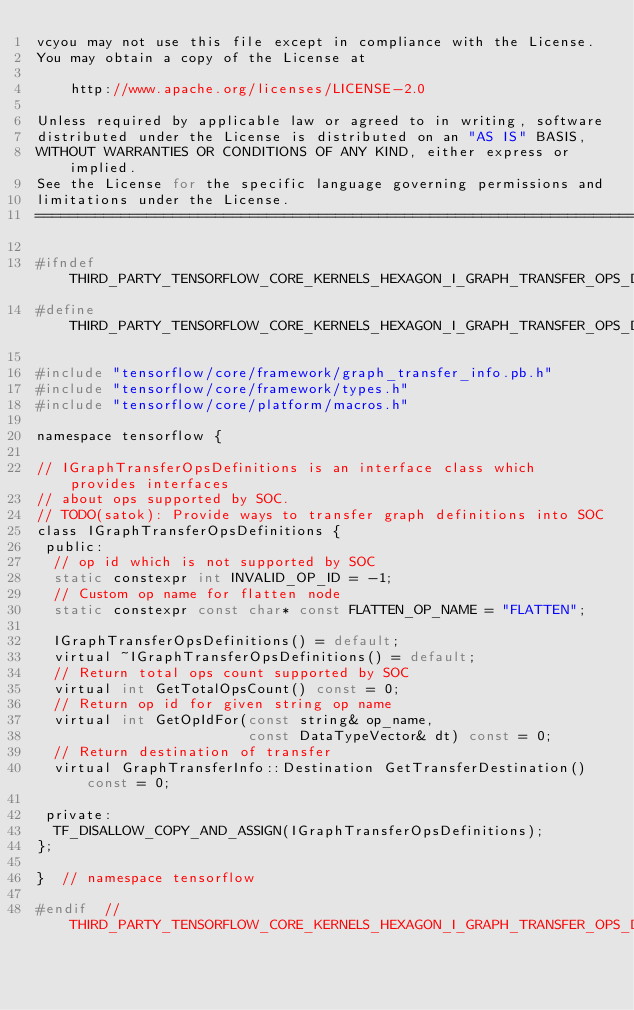<code> <loc_0><loc_0><loc_500><loc_500><_C_>vcyou may not use this file except in compliance with the License.
You may obtain a copy of the License at

    http://www.apache.org/licenses/LICENSE-2.0

Unless required by applicable law or agreed to in writing, software
distributed under the License is distributed on an "AS IS" BASIS,
WITHOUT WARRANTIES OR CONDITIONS OF ANY KIND, either express or implied.
See the License for the specific language governing permissions and
limitations under the License.
==============================================================================*/

#ifndef THIRD_PARTY_TENSORFLOW_CORE_KERNELS_HEXAGON_I_GRAPH_TRANSFER_OPS_DEFINITIONS_H_
#define THIRD_PARTY_TENSORFLOW_CORE_KERNELS_HEXAGON_I_GRAPH_TRANSFER_OPS_DEFINITIONS_H_

#include "tensorflow/core/framework/graph_transfer_info.pb.h"
#include "tensorflow/core/framework/types.h"
#include "tensorflow/core/platform/macros.h"

namespace tensorflow {

// IGraphTransferOpsDefinitions is an interface class which provides interfaces
// about ops supported by SOC.
// TODO(satok): Provide ways to transfer graph definitions into SOC
class IGraphTransferOpsDefinitions {
 public:
  // op id which is not supported by SOC
  static constexpr int INVALID_OP_ID = -1;
  // Custom op name for flatten node
  static constexpr const char* const FLATTEN_OP_NAME = "FLATTEN";

  IGraphTransferOpsDefinitions() = default;
  virtual ~IGraphTransferOpsDefinitions() = default;
  // Return total ops count supported by SOC
  virtual int GetTotalOpsCount() const = 0;
  // Return op id for given string op name
  virtual int GetOpIdFor(const string& op_name,
                         const DataTypeVector& dt) const = 0;
  // Return destination of transfer
  virtual GraphTransferInfo::Destination GetTransferDestination() const = 0;

 private:
  TF_DISALLOW_COPY_AND_ASSIGN(IGraphTransferOpsDefinitions);
};

}  // namespace tensorflow

#endif  // THIRD_PARTY_TENSORFLOW_CORE_KERNELS_HEXAGON_I_GRAPH_TRANSFER_OPS_DEFINITIONS_H_
</code> 